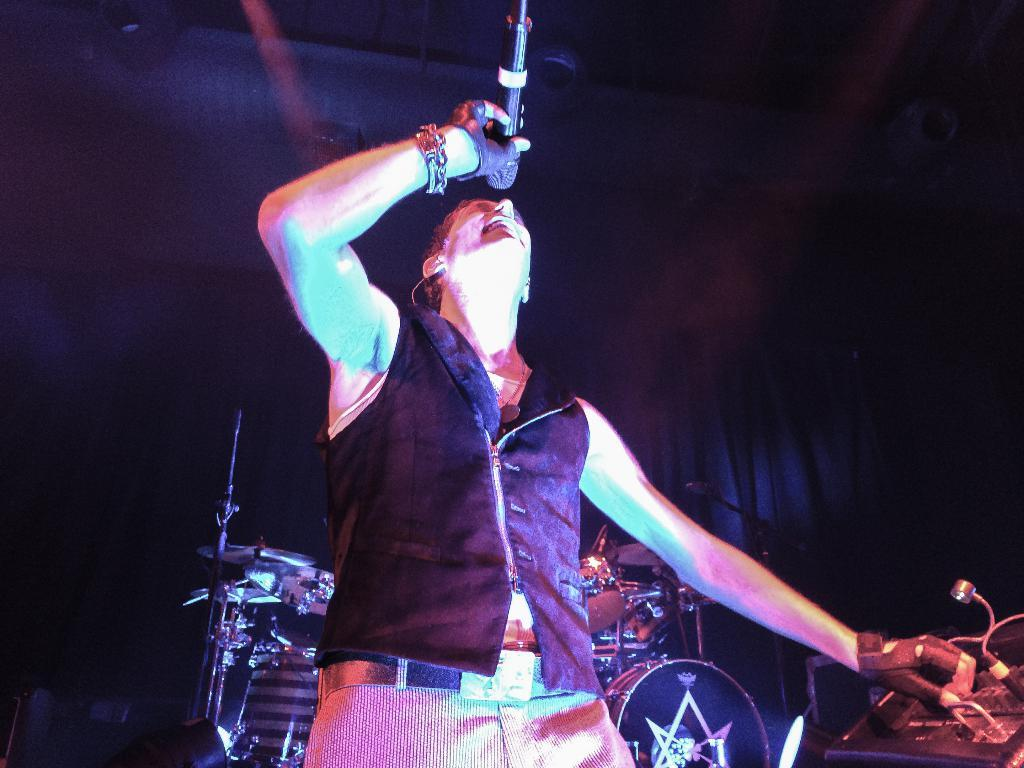What is the person in the image doing? The person is singing and holding a mic. What musical instrument can be seen in the image? There are drums visible in the image. What electronic object is present in the image? There is an electronic object in the image. What type of light is visible in the image? There is a light in the image. How would you describe the background of the image? The background of the image is dark. How many kittens are playing with the electronic object in the image? There are no kittens present in the image, and therefore no such activity can be observed. 